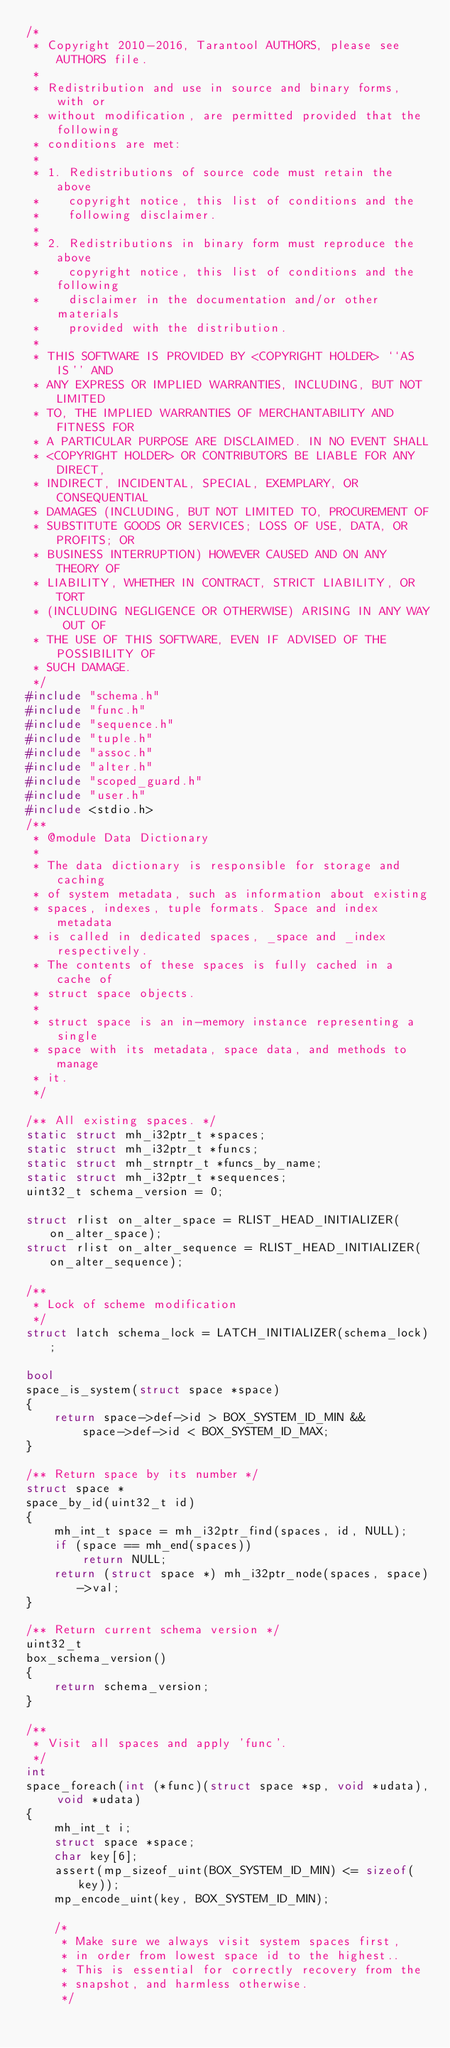<code> <loc_0><loc_0><loc_500><loc_500><_C++_>/*
 * Copyright 2010-2016, Tarantool AUTHORS, please see AUTHORS file.
 *
 * Redistribution and use in source and binary forms, with or
 * without modification, are permitted provided that the following
 * conditions are met:
 *
 * 1. Redistributions of source code must retain the above
 *    copyright notice, this list of conditions and the
 *    following disclaimer.
 *
 * 2. Redistributions in binary form must reproduce the above
 *    copyright notice, this list of conditions and the following
 *    disclaimer in the documentation and/or other materials
 *    provided with the distribution.
 *
 * THIS SOFTWARE IS PROVIDED BY <COPYRIGHT HOLDER> ``AS IS'' AND
 * ANY EXPRESS OR IMPLIED WARRANTIES, INCLUDING, BUT NOT LIMITED
 * TO, THE IMPLIED WARRANTIES OF MERCHANTABILITY AND FITNESS FOR
 * A PARTICULAR PURPOSE ARE DISCLAIMED. IN NO EVENT SHALL
 * <COPYRIGHT HOLDER> OR CONTRIBUTORS BE LIABLE FOR ANY DIRECT,
 * INDIRECT, INCIDENTAL, SPECIAL, EXEMPLARY, OR CONSEQUENTIAL
 * DAMAGES (INCLUDING, BUT NOT LIMITED TO, PROCUREMENT OF
 * SUBSTITUTE GOODS OR SERVICES; LOSS OF USE, DATA, OR PROFITS; OR
 * BUSINESS INTERRUPTION) HOWEVER CAUSED AND ON ANY THEORY OF
 * LIABILITY, WHETHER IN CONTRACT, STRICT LIABILITY, OR TORT
 * (INCLUDING NEGLIGENCE OR OTHERWISE) ARISING IN ANY WAY OUT OF
 * THE USE OF THIS SOFTWARE, EVEN IF ADVISED OF THE POSSIBILITY OF
 * SUCH DAMAGE.
 */
#include "schema.h"
#include "func.h"
#include "sequence.h"
#include "tuple.h"
#include "assoc.h"
#include "alter.h"
#include "scoped_guard.h"
#include "user.h"
#include <stdio.h>
/**
 * @module Data Dictionary
 *
 * The data dictionary is responsible for storage and caching
 * of system metadata, such as information about existing
 * spaces, indexes, tuple formats. Space and index metadata
 * is called in dedicated spaces, _space and _index respectively.
 * The contents of these spaces is fully cached in a cache of
 * struct space objects.
 *
 * struct space is an in-memory instance representing a single
 * space with its metadata, space data, and methods to manage
 * it.
 */

/** All existing spaces. */
static struct mh_i32ptr_t *spaces;
static struct mh_i32ptr_t *funcs;
static struct mh_strnptr_t *funcs_by_name;
static struct mh_i32ptr_t *sequences;
uint32_t schema_version = 0;

struct rlist on_alter_space = RLIST_HEAD_INITIALIZER(on_alter_space);
struct rlist on_alter_sequence = RLIST_HEAD_INITIALIZER(on_alter_sequence);

/**
 * Lock of scheme modification
 */
struct latch schema_lock = LATCH_INITIALIZER(schema_lock);

bool
space_is_system(struct space *space)
{
	return space->def->id > BOX_SYSTEM_ID_MIN &&
		space->def->id < BOX_SYSTEM_ID_MAX;
}

/** Return space by its number */
struct space *
space_by_id(uint32_t id)
{
	mh_int_t space = mh_i32ptr_find(spaces, id, NULL);
	if (space == mh_end(spaces))
		return NULL;
	return (struct space *) mh_i32ptr_node(spaces, space)->val;
}

/** Return current schema version */
uint32_t
box_schema_version()
{
	return schema_version;
}

/**
 * Visit all spaces and apply 'func'.
 */
int
space_foreach(int (*func)(struct space *sp, void *udata), void *udata)
{
	mh_int_t i;
	struct space *space;
	char key[6];
	assert(mp_sizeof_uint(BOX_SYSTEM_ID_MIN) <= sizeof(key));
	mp_encode_uint(key, BOX_SYSTEM_ID_MIN);

	/*
	 * Make sure we always visit system spaces first,
	 * in order from lowest space id to the highest..
	 * This is essential for correctly recovery from the
	 * snapshot, and harmless otherwise.
	 */</code> 